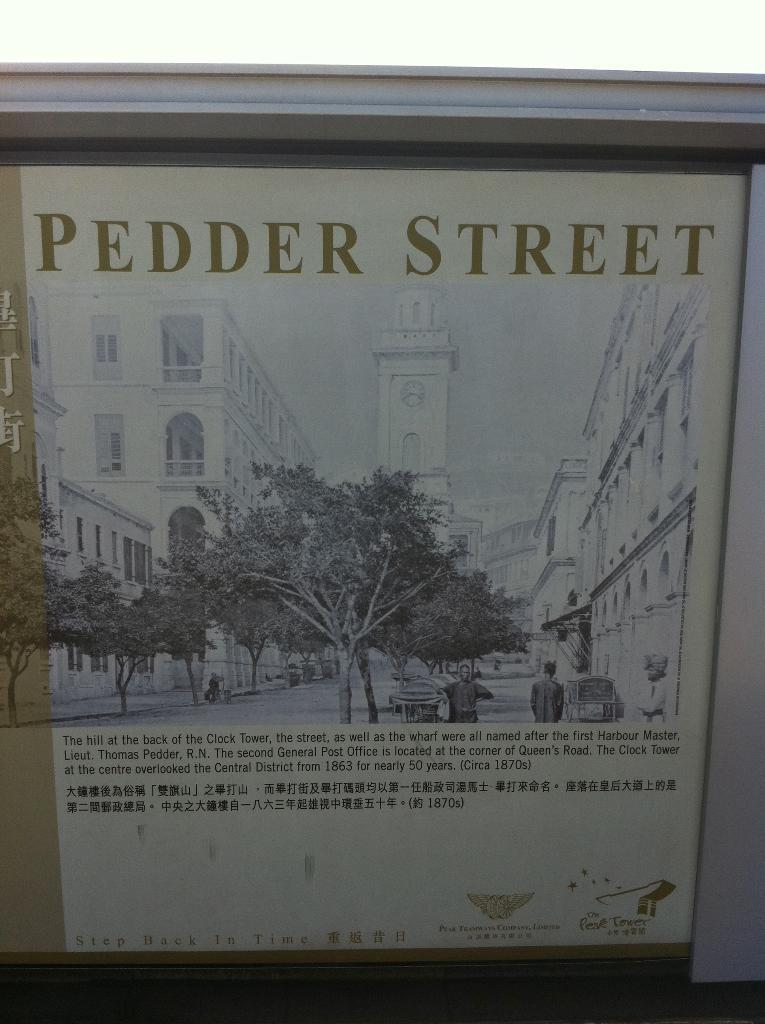What is the main subject of the poster in the image? The poster contains images of buildings, trees, people, and objects. Can you describe the images on the poster? The poster contains images of buildings, trees, people, and objects. Are there any words on the poster? Yes, there are words on the poster. How many sticks can be seen in the image? There are no sticks present in the image; it features a poster with images of buildings, trees, people, and objects, as well as words. Is there a watch visible on the poster? There is no watch present on the poster; it contains images of buildings, trees, people, and objects, along with words. 